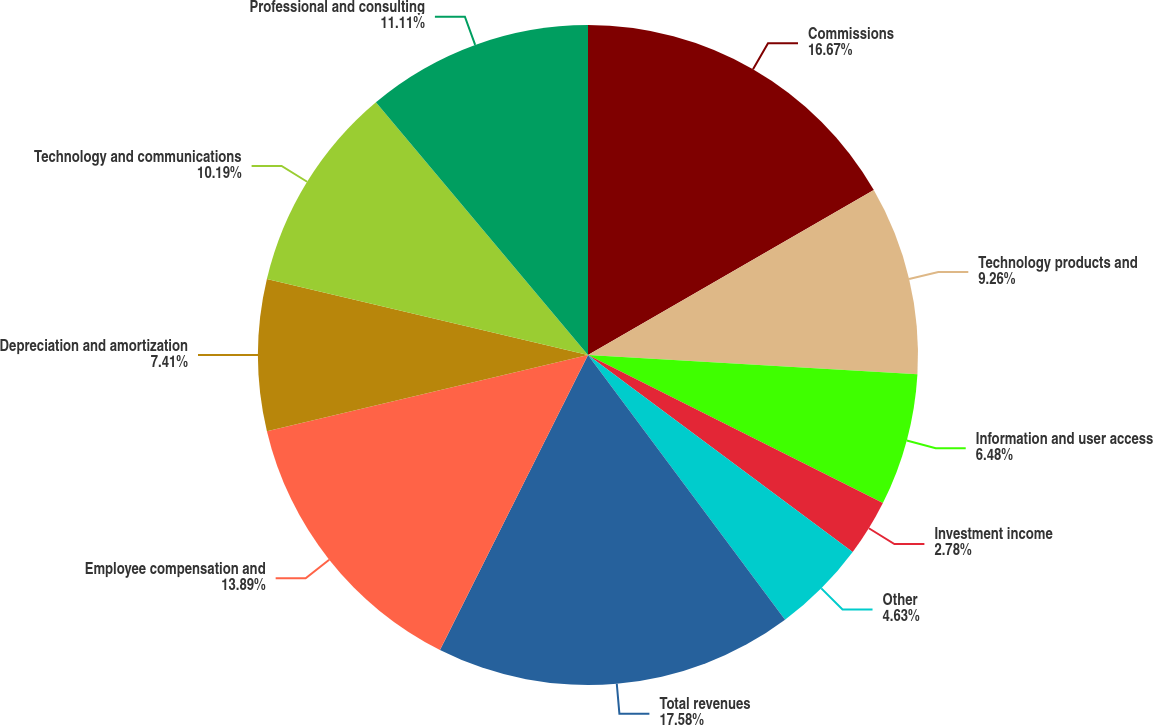Convert chart to OTSL. <chart><loc_0><loc_0><loc_500><loc_500><pie_chart><fcel>Commissions<fcel>Technology products and<fcel>Information and user access<fcel>Investment income<fcel>Other<fcel>Total revenues<fcel>Employee compensation and<fcel>Depreciation and amortization<fcel>Technology and communications<fcel>Professional and consulting<nl><fcel>16.67%<fcel>9.26%<fcel>6.48%<fcel>2.78%<fcel>4.63%<fcel>17.59%<fcel>13.89%<fcel>7.41%<fcel>10.19%<fcel>11.11%<nl></chart> 